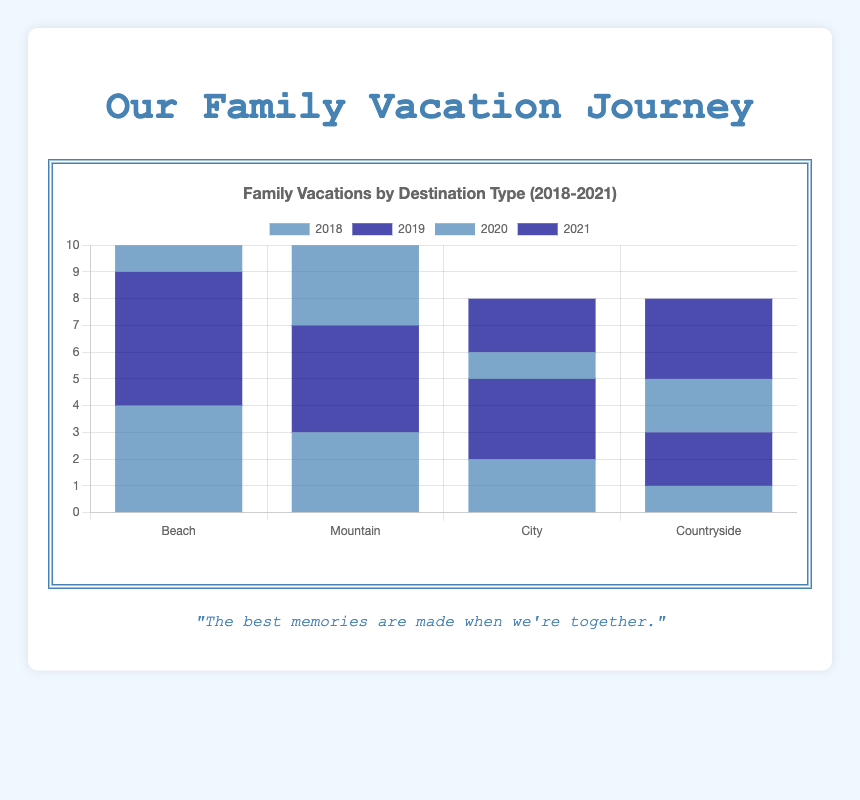Which year did the Beach destination have the highest frequency of family vacations? The figure shows the frequency of family vacations to each type of destination by year. To find the year when the Beach destination had the highest frequency, compare the heights of the blue and dark blue bars for the Beach category from 2018 to 2021. The highest bar for the Beach category is in 2019.
Answer: 2019 What is the total frequency of family vacations to the Mountain destination over all years? To find the total frequency, add the number of vacations to the Mountain destination from 2018 to 2021. From the data, these are 3 (2018) + 4 (2019) + 6 (2020) + 2 (2021), resulting in a total of 15.
Answer: 15 How does the frequency of Countryside vacations in Fall 2019 compare to Spring 2018 City vacations? From the figure, compare the heights of the bars representing Countryside in Fall 2019 and City in Spring 2018. Countryside in Fall 2019 has a frequency of 2, which is higher than the City in Spring 2018, which has a frequency of 2.
Answer: Equal Which time period had the lowest frequency of family vacations to any destination? Identify the shortest bar among all destinations over the different years. The City destination in Spring 2020 has the shortest bar, indicating the lowest frequency of 1.
Answer: Spring 2020 What is the average frequency of family vacations to the City destination across all years? To calculate the average frequency, add the frequencies of City vacations across all years and divide by the number of years. The frequencies are 2 (2018) + 3 (2019) + 1 (2020) + 2 (2021), so the average is (2 + 3 + 1 + 2) / 4 = 2.
Answer: 2 Did the frequency of Mountain vacations increase or decrease from Winter 2020 to Winter 2021? Compare the heights of the bars for Mountain vacations in Winter 2020 and Winter 2021. The frequency decreased from 6 in 2020 to 2 in 2021.
Answer: Decrease Which destination saw the highest frequency of family vacations in Summer 2020? Look at the blue and dark blue bars for the year 2020 for each destination. The Mountain destination has the highest bar in Summer 2020 with a frequency of 6.
Answer: Mountain How many more family vacations were taken to the Beach destination in Summer 2019 compared to Summer 2020? Subtract the frequency of Beach vacations in Summer 2020 from the frequency in Summer 2019. This is 5 (2019) - 2 (2020) = 3 more vacations.
Answer: 3 What is the difference in the total frequency of Beach and Mountain vacations in 2021? Calculate the total frequency for each destination in 2021 and find the difference. The frequencies are 3 (Beach) and 2 (Mountain), so the difference is 3 - 2 = 1.
Answer: 1 Which destination experienced the most significant drop in vacation frequency between any two consecutive years? Examine the changes in frequency for each destination between consecutive years. Mountain from 2020 (6) to 2021 (2) shows the most significant drop, a decrease of 4.
Answer: Mountain 